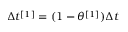Convert formula to latex. <formula><loc_0><loc_0><loc_500><loc_500>\Delta t ^ { [ 1 ] } = ( 1 - \theta ^ { [ 1 ] } ) \Delta t</formula> 